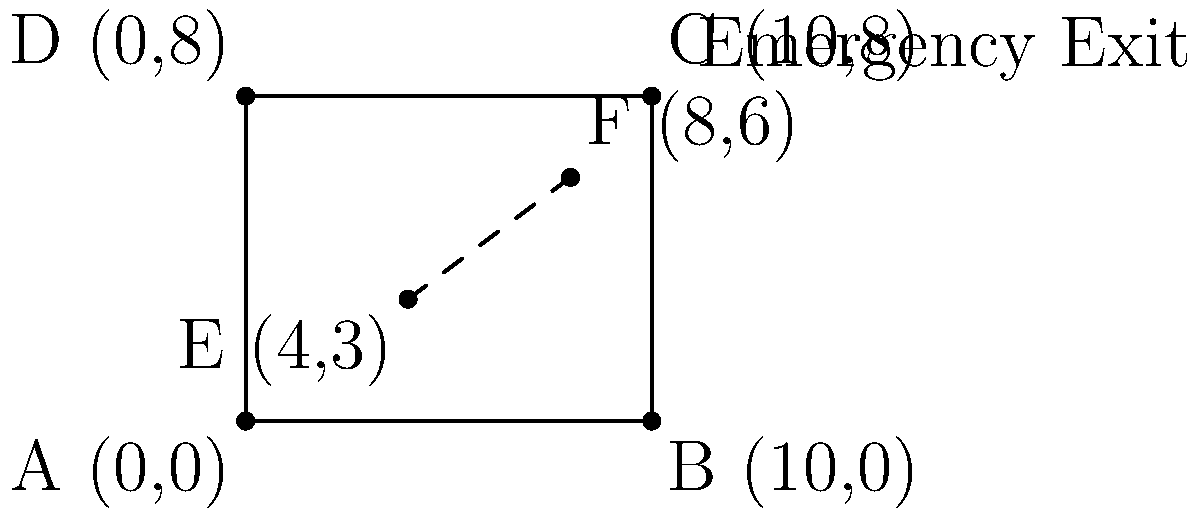In a pharmacy blueprint, the main storage area is represented by a rectangle ABCD with coordinates A(0,0), B(10,0), C(10,8), and D(0,8). An aisle runs diagonally from point E(4,3) to point F(8,6). To comply with safety regulations, an emergency exit must be placed on the wall BC, such that it is equidistant from points E and F. Determine the coordinates of the emergency exit. To find the coordinates of the emergency exit, we'll follow these steps:

1) The emergency exit should be equidistant from E and F, so it must lie on the perpendicular bisector of line segment EF.

2) Let's find the midpoint of EF:
   $M_x = \frac{x_E + x_F}{2} = \frac{4 + 8}{2} = 6$
   $M_y = \frac{y_E + y_F}{2} = \frac{3 + 6}{2} = 4.5$
   So, M(6, 4.5)

3) The slope of EF is:
   $m_{EF} = \frac{y_F - y_E}{x_F - x_E} = \frac{6 - 3}{8 - 4} = \frac{3}{4} = 0.75$

4) The slope of the perpendicular bisector is the negative reciprocal:
   $m_{\perp} = -\frac{1}{m_{EF}} = -\frac{4}{3} \approx -1.33$

5) Using the point-slope form of a line equation with M(6, 4.5):
   $y - 4.5 = -\frac{4}{3}(x - 6)$

6) The wall BC has the equation $x = 10$. To find where the perpendicular bisector intersects BC, substitute $x = 10$:
   $y - 4.5 = -\frac{4}{3}(10 - 6)$
   $y - 4.5 = -\frac{16}{3}$
   $y = 4.5 - \frac{16}{3} = \frac{13.5 - 16}{3} = -\frac{2.5}{3} \approx 0.833$

7) Therefore, the emergency exit should be placed at (10, $-\frac{2.5}{3}$) or approximately (10, 0.833).
Answer: (10, $-\frac{2.5}{3}$) or (10, 0.833) 